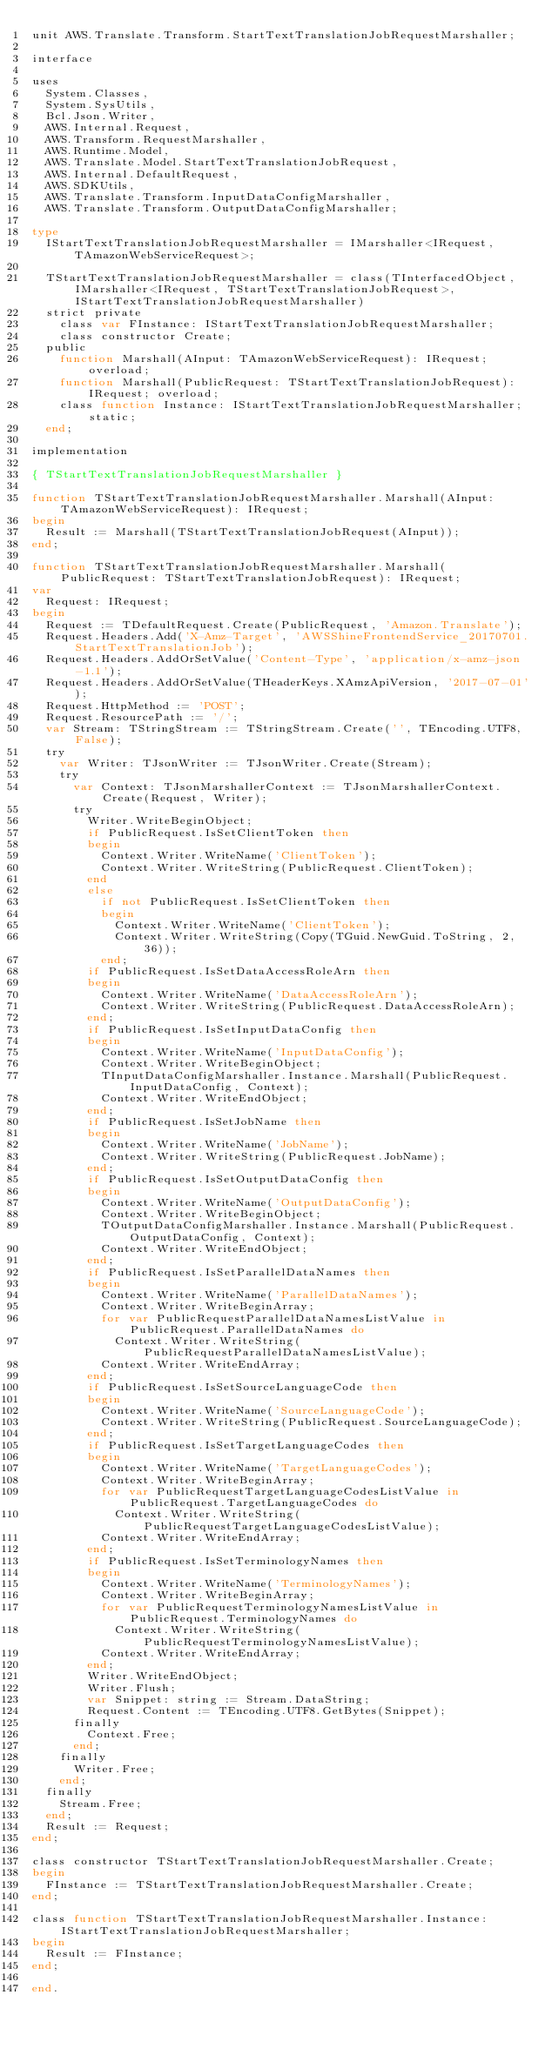Convert code to text. <code><loc_0><loc_0><loc_500><loc_500><_Pascal_>unit AWS.Translate.Transform.StartTextTranslationJobRequestMarshaller;

interface

uses
  System.Classes, 
  System.SysUtils, 
  Bcl.Json.Writer, 
  AWS.Internal.Request, 
  AWS.Transform.RequestMarshaller, 
  AWS.Runtime.Model, 
  AWS.Translate.Model.StartTextTranslationJobRequest, 
  AWS.Internal.DefaultRequest, 
  AWS.SDKUtils, 
  AWS.Translate.Transform.InputDataConfigMarshaller, 
  AWS.Translate.Transform.OutputDataConfigMarshaller;

type
  IStartTextTranslationJobRequestMarshaller = IMarshaller<IRequest, TAmazonWebServiceRequest>;
  
  TStartTextTranslationJobRequestMarshaller = class(TInterfacedObject, IMarshaller<IRequest, TStartTextTranslationJobRequest>, IStartTextTranslationJobRequestMarshaller)
  strict private
    class var FInstance: IStartTextTranslationJobRequestMarshaller;
    class constructor Create;
  public
    function Marshall(AInput: TAmazonWebServiceRequest): IRequest; overload;
    function Marshall(PublicRequest: TStartTextTranslationJobRequest): IRequest; overload;
    class function Instance: IStartTextTranslationJobRequestMarshaller; static;
  end;
  
implementation

{ TStartTextTranslationJobRequestMarshaller }

function TStartTextTranslationJobRequestMarshaller.Marshall(AInput: TAmazonWebServiceRequest): IRequest;
begin
  Result := Marshall(TStartTextTranslationJobRequest(AInput));
end;

function TStartTextTranslationJobRequestMarshaller.Marshall(PublicRequest: TStartTextTranslationJobRequest): IRequest;
var
  Request: IRequest;
begin
  Request := TDefaultRequest.Create(PublicRequest, 'Amazon.Translate');
  Request.Headers.Add('X-Amz-Target', 'AWSShineFrontendService_20170701.StartTextTranslationJob');
  Request.Headers.AddOrSetValue('Content-Type', 'application/x-amz-json-1.1');
  Request.Headers.AddOrSetValue(THeaderKeys.XAmzApiVersion, '2017-07-01');
  Request.HttpMethod := 'POST';
  Request.ResourcePath := '/';
  var Stream: TStringStream := TStringStream.Create('', TEncoding.UTF8, False);
  try
    var Writer: TJsonWriter := TJsonWriter.Create(Stream);
    try
      var Context: TJsonMarshallerContext := TJsonMarshallerContext.Create(Request, Writer);
      try
        Writer.WriteBeginObject;
        if PublicRequest.IsSetClientToken then
        begin
          Context.Writer.WriteName('ClientToken');
          Context.Writer.WriteString(PublicRequest.ClientToken);
        end
        else
          if not PublicRequest.IsSetClientToken then
          begin
            Context.Writer.WriteName('ClientToken');
            Context.Writer.WriteString(Copy(TGuid.NewGuid.ToString, 2, 36));
          end;
        if PublicRequest.IsSetDataAccessRoleArn then
        begin
          Context.Writer.WriteName('DataAccessRoleArn');
          Context.Writer.WriteString(PublicRequest.DataAccessRoleArn);
        end;
        if PublicRequest.IsSetInputDataConfig then
        begin
          Context.Writer.WriteName('InputDataConfig');
          Context.Writer.WriteBeginObject;
          TInputDataConfigMarshaller.Instance.Marshall(PublicRequest.InputDataConfig, Context);
          Context.Writer.WriteEndObject;
        end;
        if PublicRequest.IsSetJobName then
        begin
          Context.Writer.WriteName('JobName');
          Context.Writer.WriteString(PublicRequest.JobName);
        end;
        if PublicRequest.IsSetOutputDataConfig then
        begin
          Context.Writer.WriteName('OutputDataConfig');
          Context.Writer.WriteBeginObject;
          TOutputDataConfigMarshaller.Instance.Marshall(PublicRequest.OutputDataConfig, Context);
          Context.Writer.WriteEndObject;
        end;
        if PublicRequest.IsSetParallelDataNames then
        begin
          Context.Writer.WriteName('ParallelDataNames');
          Context.Writer.WriteBeginArray;
          for var PublicRequestParallelDataNamesListValue in PublicRequest.ParallelDataNames do
            Context.Writer.WriteString(PublicRequestParallelDataNamesListValue);
          Context.Writer.WriteEndArray;
        end;
        if PublicRequest.IsSetSourceLanguageCode then
        begin
          Context.Writer.WriteName('SourceLanguageCode');
          Context.Writer.WriteString(PublicRequest.SourceLanguageCode);
        end;
        if PublicRequest.IsSetTargetLanguageCodes then
        begin
          Context.Writer.WriteName('TargetLanguageCodes');
          Context.Writer.WriteBeginArray;
          for var PublicRequestTargetLanguageCodesListValue in PublicRequest.TargetLanguageCodes do
            Context.Writer.WriteString(PublicRequestTargetLanguageCodesListValue);
          Context.Writer.WriteEndArray;
        end;
        if PublicRequest.IsSetTerminologyNames then
        begin
          Context.Writer.WriteName('TerminologyNames');
          Context.Writer.WriteBeginArray;
          for var PublicRequestTerminologyNamesListValue in PublicRequest.TerminologyNames do
            Context.Writer.WriteString(PublicRequestTerminologyNamesListValue);
          Context.Writer.WriteEndArray;
        end;
        Writer.WriteEndObject;
        Writer.Flush;
        var Snippet: string := Stream.DataString;
        Request.Content := TEncoding.UTF8.GetBytes(Snippet);
      finally
        Context.Free;
      end;
    finally
      Writer.Free;
    end;
  finally
    Stream.Free;
  end;
  Result := Request;
end;

class constructor TStartTextTranslationJobRequestMarshaller.Create;
begin
  FInstance := TStartTextTranslationJobRequestMarshaller.Create;
end;

class function TStartTextTranslationJobRequestMarshaller.Instance: IStartTextTranslationJobRequestMarshaller;
begin
  Result := FInstance;
end;

end.
</code> 